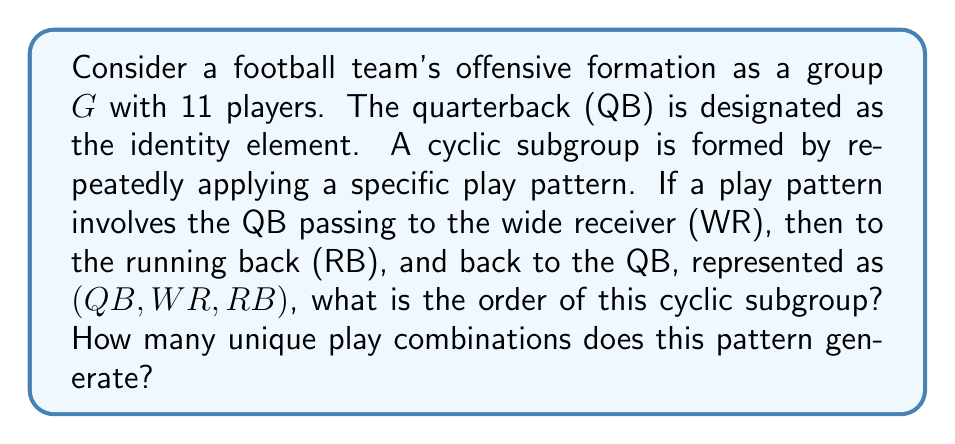Solve this math problem. To solve this problem, we need to analyze the cyclic subgroup generated by the given play pattern. Let's approach this step-by-step:

1) The play pattern is represented as $(QB, WR, RB)$. This can be considered as a permutation in cycle notation.

2) To find the order of the cyclic subgroup, we need to determine how many times we need to apply this pattern to return to the identity element (QB).

3) Let's apply the pattern repeatedly:
   - $(QB, WR, RB)^1 = (QB, WR, RB)$
   - $(QB, WR, RB)^2 = (QB, RB, WR)$
   - $(QB, WR, RB)^3 = (QB, QB, QB) = (QB)$ (identity)

4) We see that after applying the pattern 3 times, we return to the identity element (QB).

5) Therefore, the order of this cyclic subgroup is 3.

6) The unique play combinations generated by this pattern are:
   - $(QB, WR, RB)$
   - $(QB, RB, WR)$
   - $(QB)$ (identity)

Thus, this cyclic subgroup generates 3 unique play combinations.

In group theory terms, we have found that $\langle (QB, WR, RB) \rangle = \{(QB), (QB, WR, RB), (QB, RB, WR)\}$, which is a cyclic subgroup of order 3.
Answer: The order of the cyclic subgroup is 3, and it generates 3 unique play combinations. 